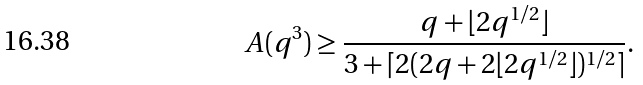<formula> <loc_0><loc_0><loc_500><loc_500>A ( q ^ { 3 } ) \geq \frac { q + \lfloor 2 q ^ { 1 / 2 } \rfloor } { 3 + \lceil 2 ( 2 q + 2 \lfloor 2 q ^ { 1 / 2 } \rfloor ) ^ { 1 / 2 } \rceil } .</formula> 